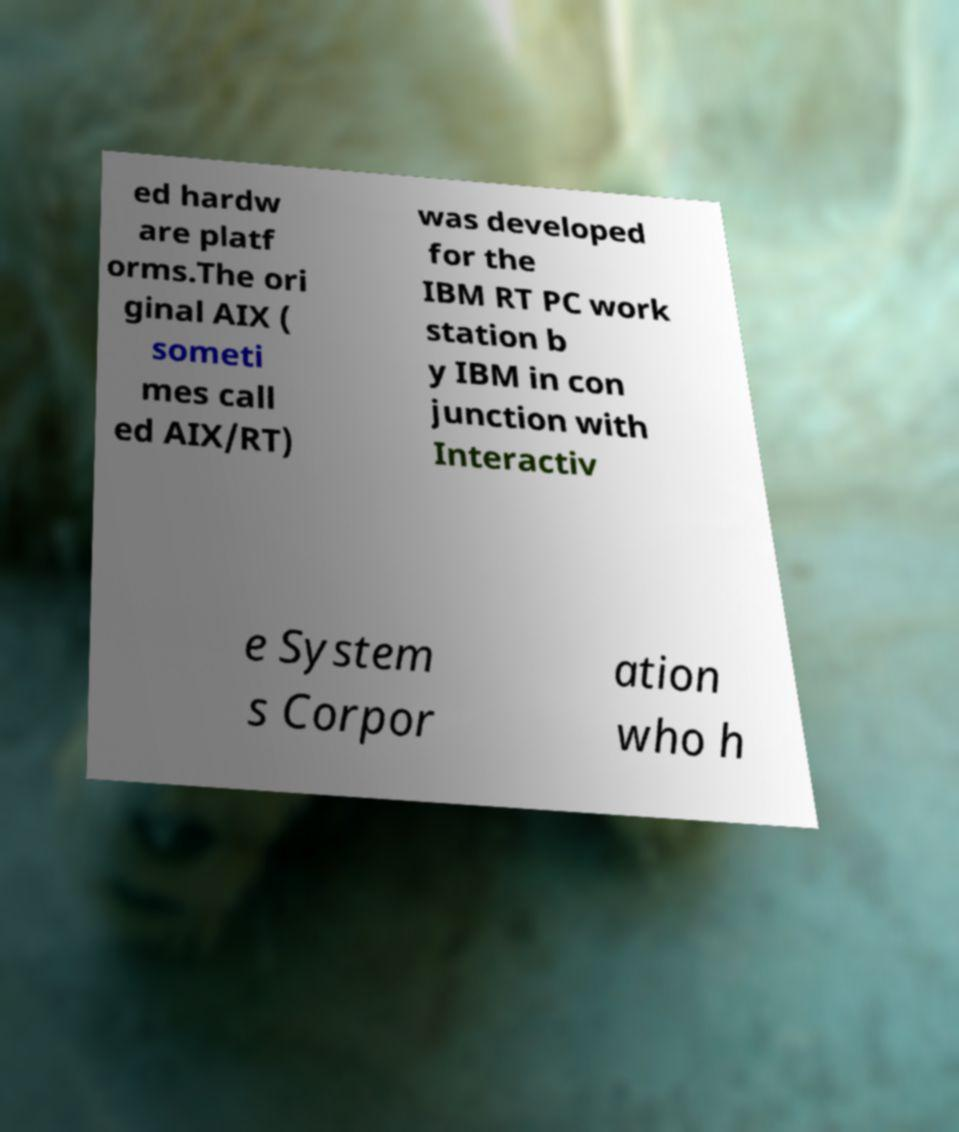I need the written content from this picture converted into text. Can you do that? ed hardw are platf orms.The ori ginal AIX ( someti mes call ed AIX/RT) was developed for the IBM RT PC work station b y IBM in con junction with Interactiv e System s Corpor ation who h 